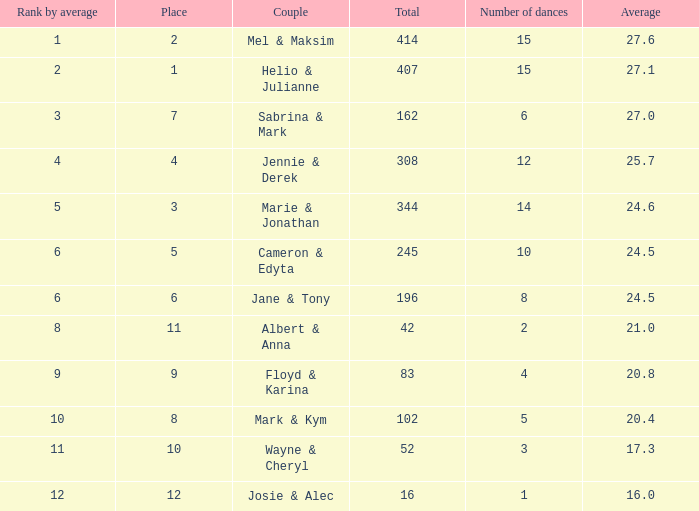What is the average when the rank by average is more than 12? None. 